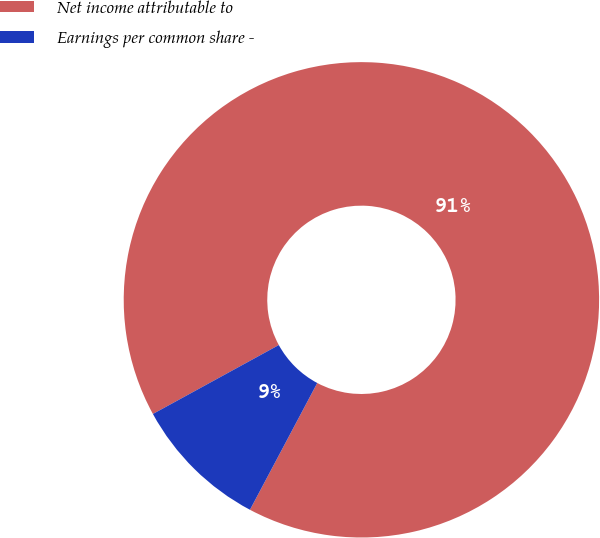Convert chart to OTSL. <chart><loc_0><loc_0><loc_500><loc_500><pie_chart><fcel>Net income attributable to<fcel>Earnings per common share -<nl><fcel>90.74%<fcel>9.26%<nl></chart> 